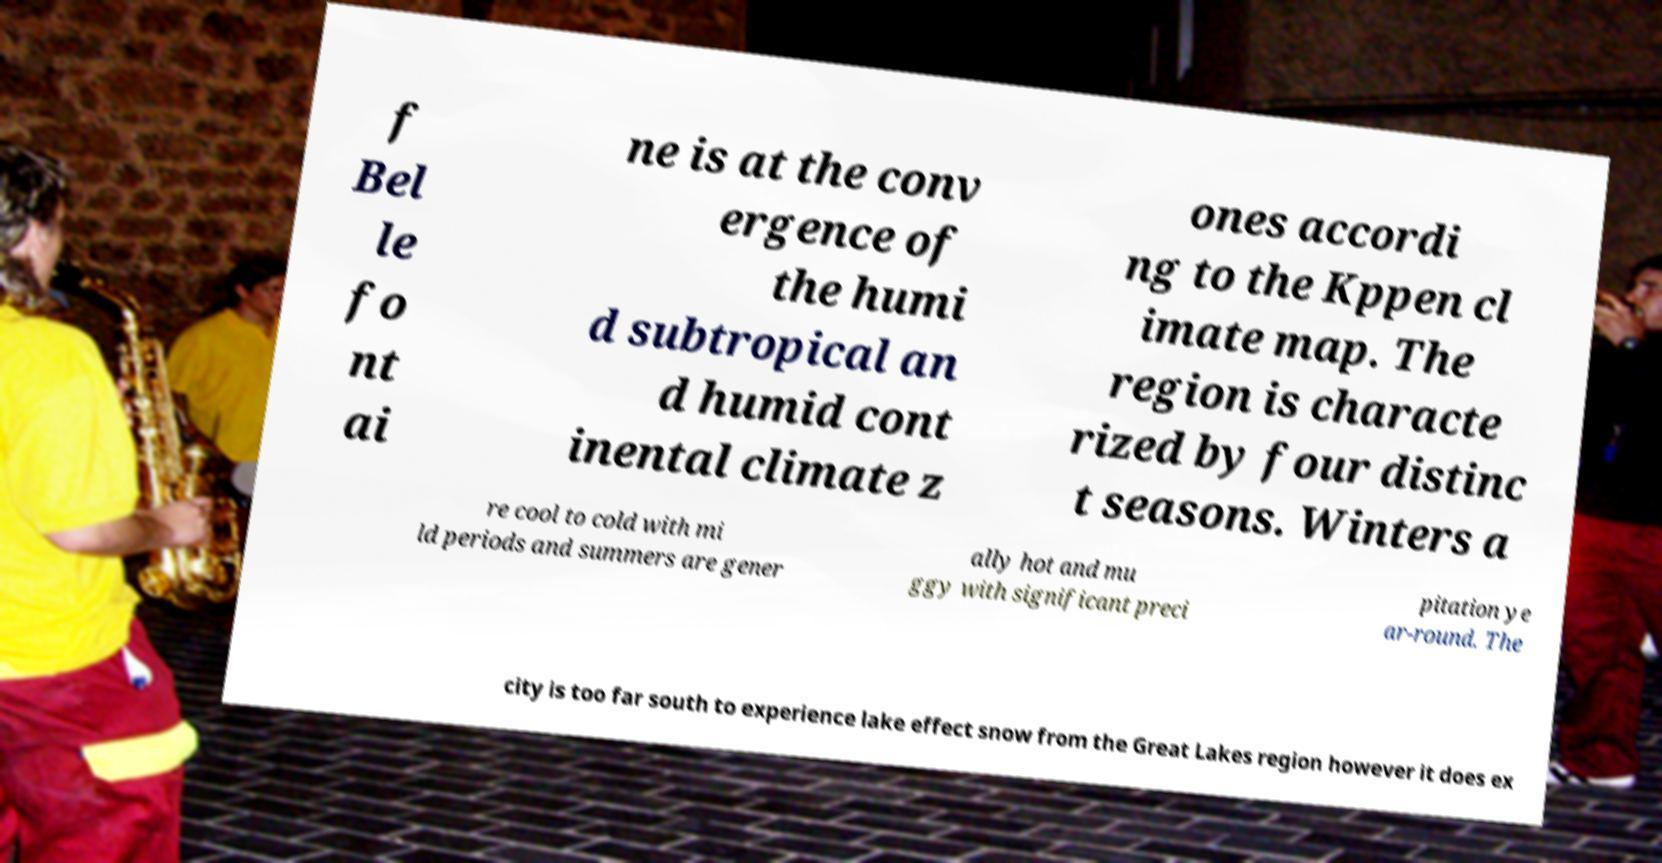Can you accurately transcribe the text from the provided image for me? f Bel le fo nt ai ne is at the conv ergence of the humi d subtropical an d humid cont inental climate z ones accordi ng to the Kppen cl imate map. The region is characte rized by four distinc t seasons. Winters a re cool to cold with mi ld periods and summers are gener ally hot and mu ggy with significant preci pitation ye ar-round. The city is too far south to experience lake effect snow from the Great Lakes region however it does ex 